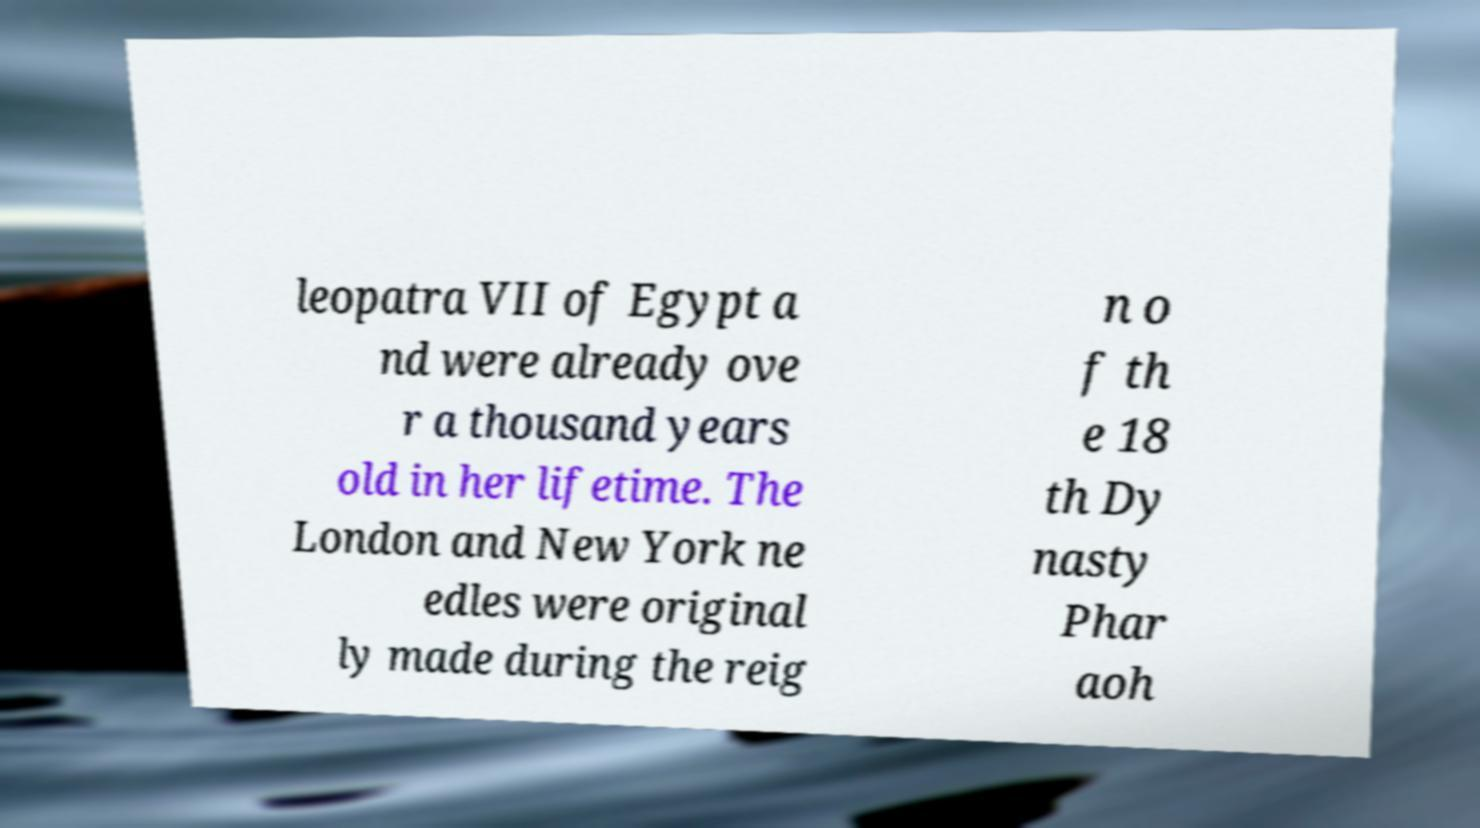I need the written content from this picture converted into text. Can you do that? leopatra VII of Egypt a nd were already ove r a thousand years old in her lifetime. The London and New York ne edles were original ly made during the reig n o f th e 18 th Dy nasty Phar aoh 